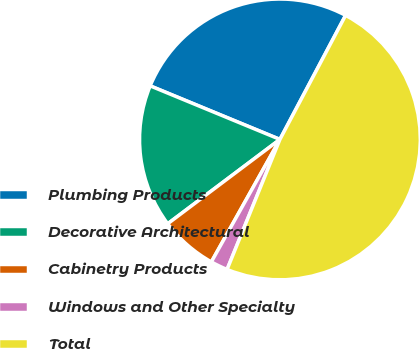Convert chart. <chart><loc_0><loc_0><loc_500><loc_500><pie_chart><fcel>Plumbing Products<fcel>Decorative Architectural<fcel>Cabinetry Products<fcel>Windows and Other Specialty<fcel>Total<nl><fcel>26.52%<fcel>16.49%<fcel>6.62%<fcel>1.98%<fcel>48.4%<nl></chart> 